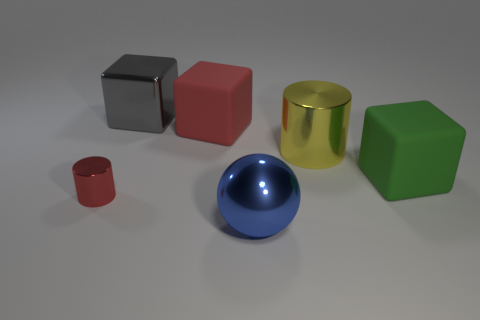Is there any other thing of the same color as the small metallic thing?
Provide a succinct answer. Yes. Does the rubber block that is to the left of the blue ball have the same color as the cylinder left of the large yellow cylinder?
Keep it short and to the point. Yes. Does the tiny metal cylinder have the same color as the big matte object that is behind the big green cube?
Provide a succinct answer. Yes. The object that is made of the same material as the big red block is what shape?
Your response must be concise. Cube. What number of gray things are either small metal cylinders or metal cubes?
Offer a very short reply. 1. There is a shiny thing that is behind the large matte block on the left side of the big blue ball; are there any large blocks that are on the right side of it?
Provide a succinct answer. Yes. Is the number of red cubes less than the number of big cyan objects?
Give a very brief answer. No. There is a thing that is behind the big red block; is it the same shape as the red metal object?
Provide a succinct answer. No. Are any small gray rubber blocks visible?
Offer a terse response. No. There is a ball in front of the red thing in front of the large block that is on the right side of the large red block; what is its color?
Your answer should be very brief. Blue. 